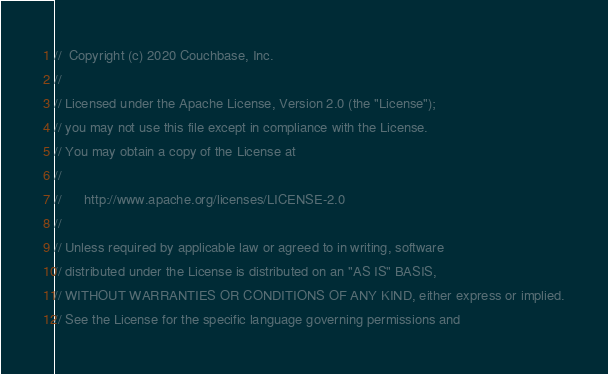Convert code to text. <code><loc_0><loc_0><loc_500><loc_500><_Go_>//  Copyright (c) 2020 Couchbase, Inc.
//
// Licensed under the Apache License, Version 2.0 (the "License");
// you may not use this file except in compliance with the License.
// You may obtain a copy of the License at
//
// 		http://www.apache.org/licenses/LICENSE-2.0
//
// Unless required by applicable law or agreed to in writing, software
// distributed under the License is distributed on an "AS IS" BASIS,
// WITHOUT WARRANTIES OR CONDITIONS OF ANY KIND, either express or implied.
// See the License for the specific language governing permissions and</code> 